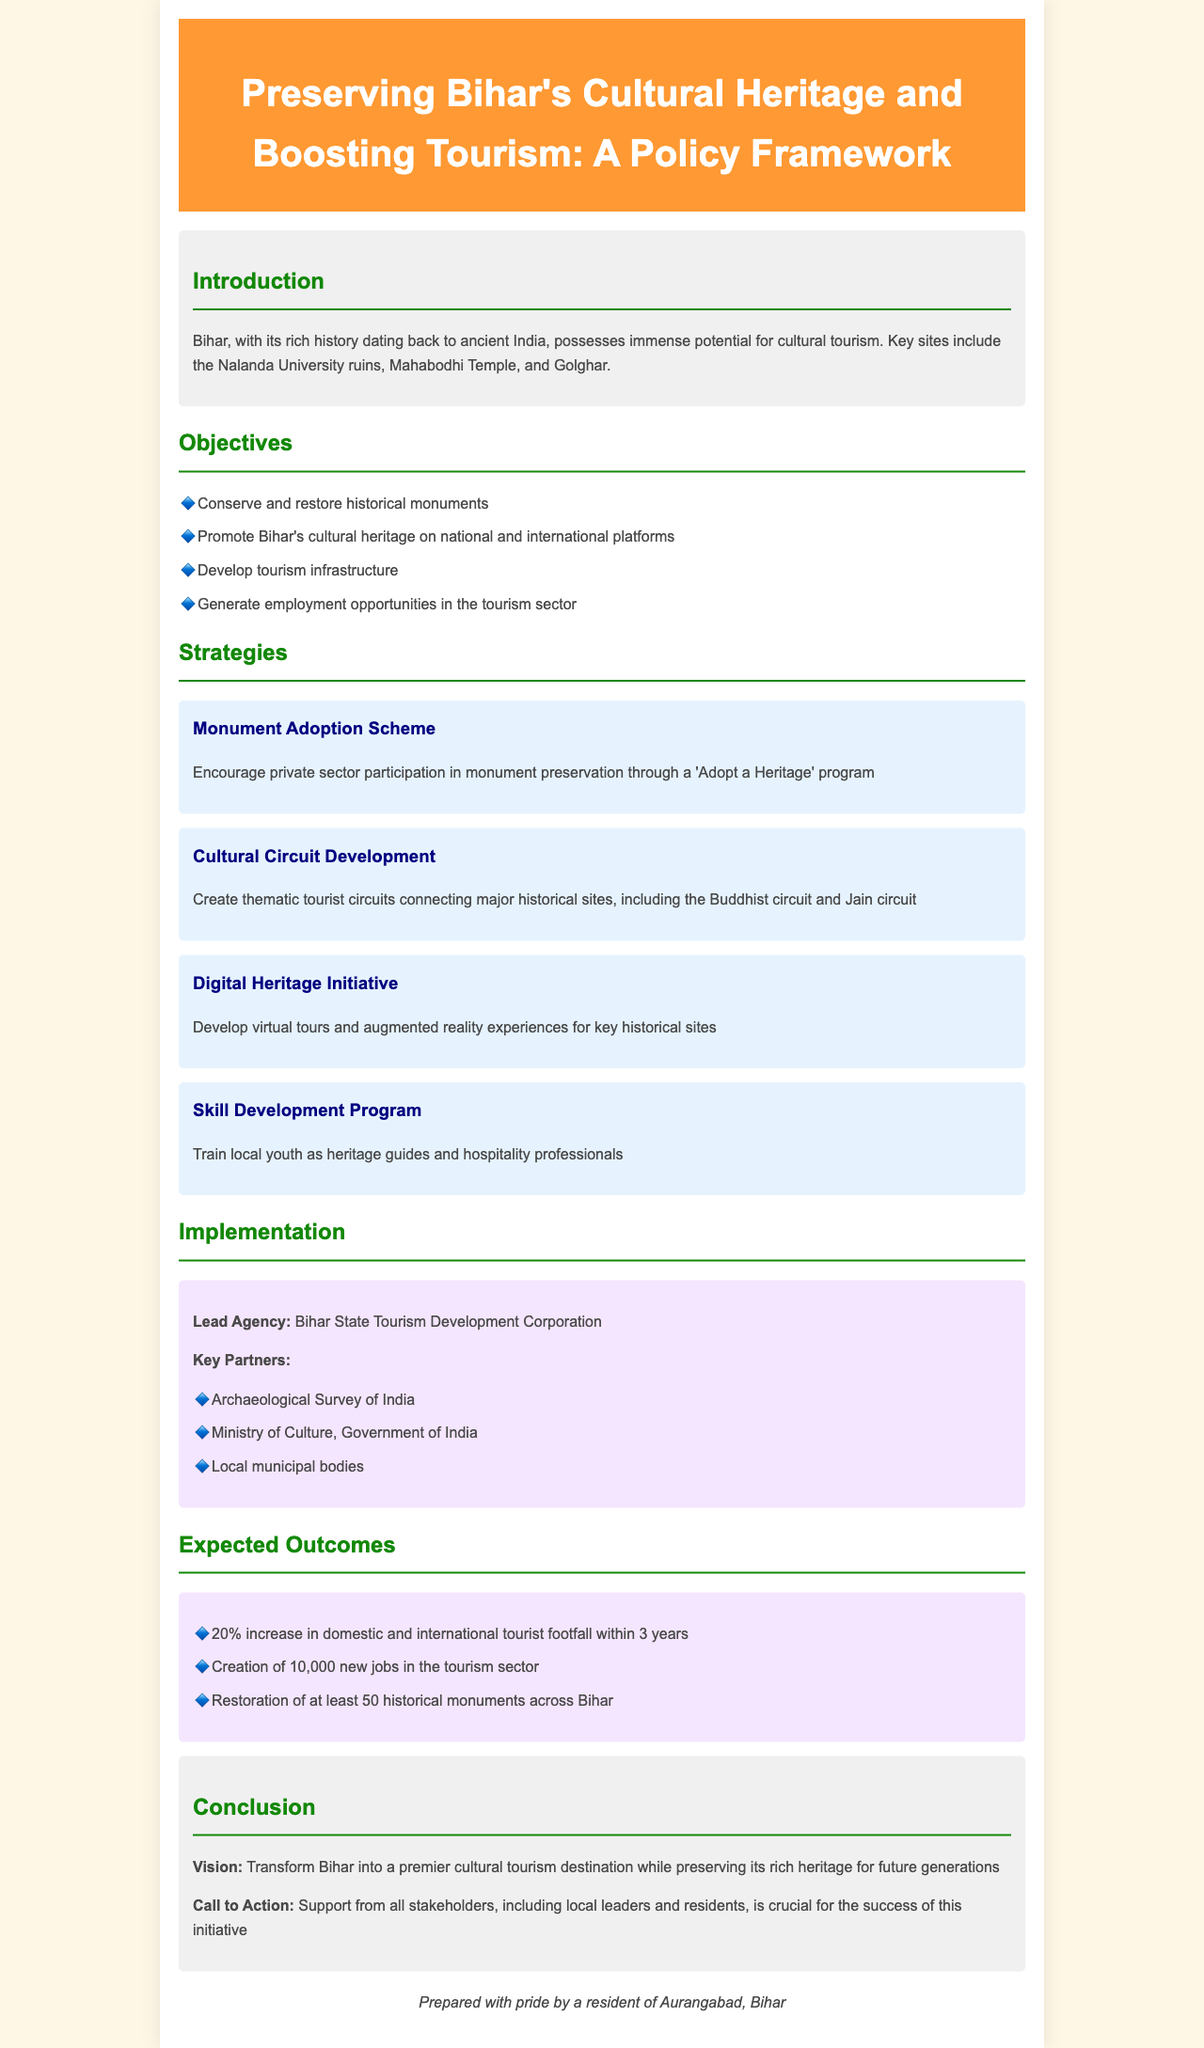What are the key tourist sites mentioned? The document lists important cultural sites in Bihar, such as Nalanda University ruins, Mahabodhi Temple, and Golghar.
Answer: Nalanda University ruins, Mahabodhi Temple, Golghar What is the first objective outlined in the document? The first objective specified in the document is to conserve and restore historical monuments.
Answer: Conserve and restore historical monuments Which organization is the lead agency for the implementation? The lead agency responsible for implementing the policy is mentioned in the document.
Answer: Bihar State Tourism Development Corporation What is the expected job creation in the tourism sector? The expected number of new jobs created within the tourism sector is provided in the outcomes section of the document.
Answer: 10,000 What program aims to train local youth? The document mentions a specific program designed to educate local youth for a particular role in the tourism industry.
Answer: Skill Development Program How many historical monuments are expected to be restored? The document quantifies the number of historical monuments to be restored as an outcome of the policy framework.
Answer: 50 What type of partnership is encouraged for monument preservation? The document mentions a specific scheme promoting private sector participation in preservation efforts.
Answer: Monument Adoption Scheme What is the overall vision of the policy? The vision outlined in the conclusion section reflects a long-term goal for Bihar regarding cultural tourism.
Answer: Transform Bihar into a premier cultural tourism destination What do the cultural circuits aim to connect? The document specifies what the thematic tourist circuits are designed to link together.
Answer: Major historical sites 